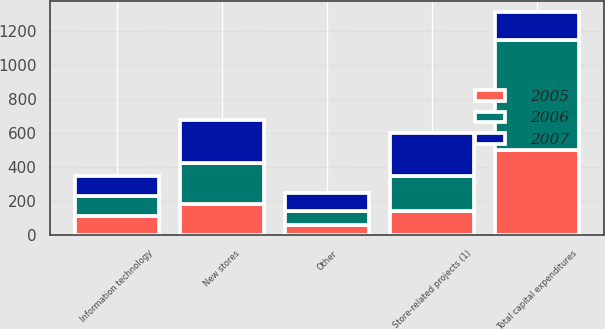Convert chart to OTSL. <chart><loc_0><loc_0><loc_500><loc_500><stacked_bar_chart><ecel><fcel>New stores<fcel>Store-related projects (1)<fcel>Information technology<fcel>Other<fcel>Total capital expenditures<nl><fcel>2007<fcel>253<fcel>251<fcel>121<fcel>108<fcel>163.5<nl><fcel>2006<fcel>244<fcel>206<fcel>115<fcel>83<fcel>648<nl><fcel>2005<fcel>182<fcel>145<fcel>115<fcel>60<fcel>502<nl></chart> 